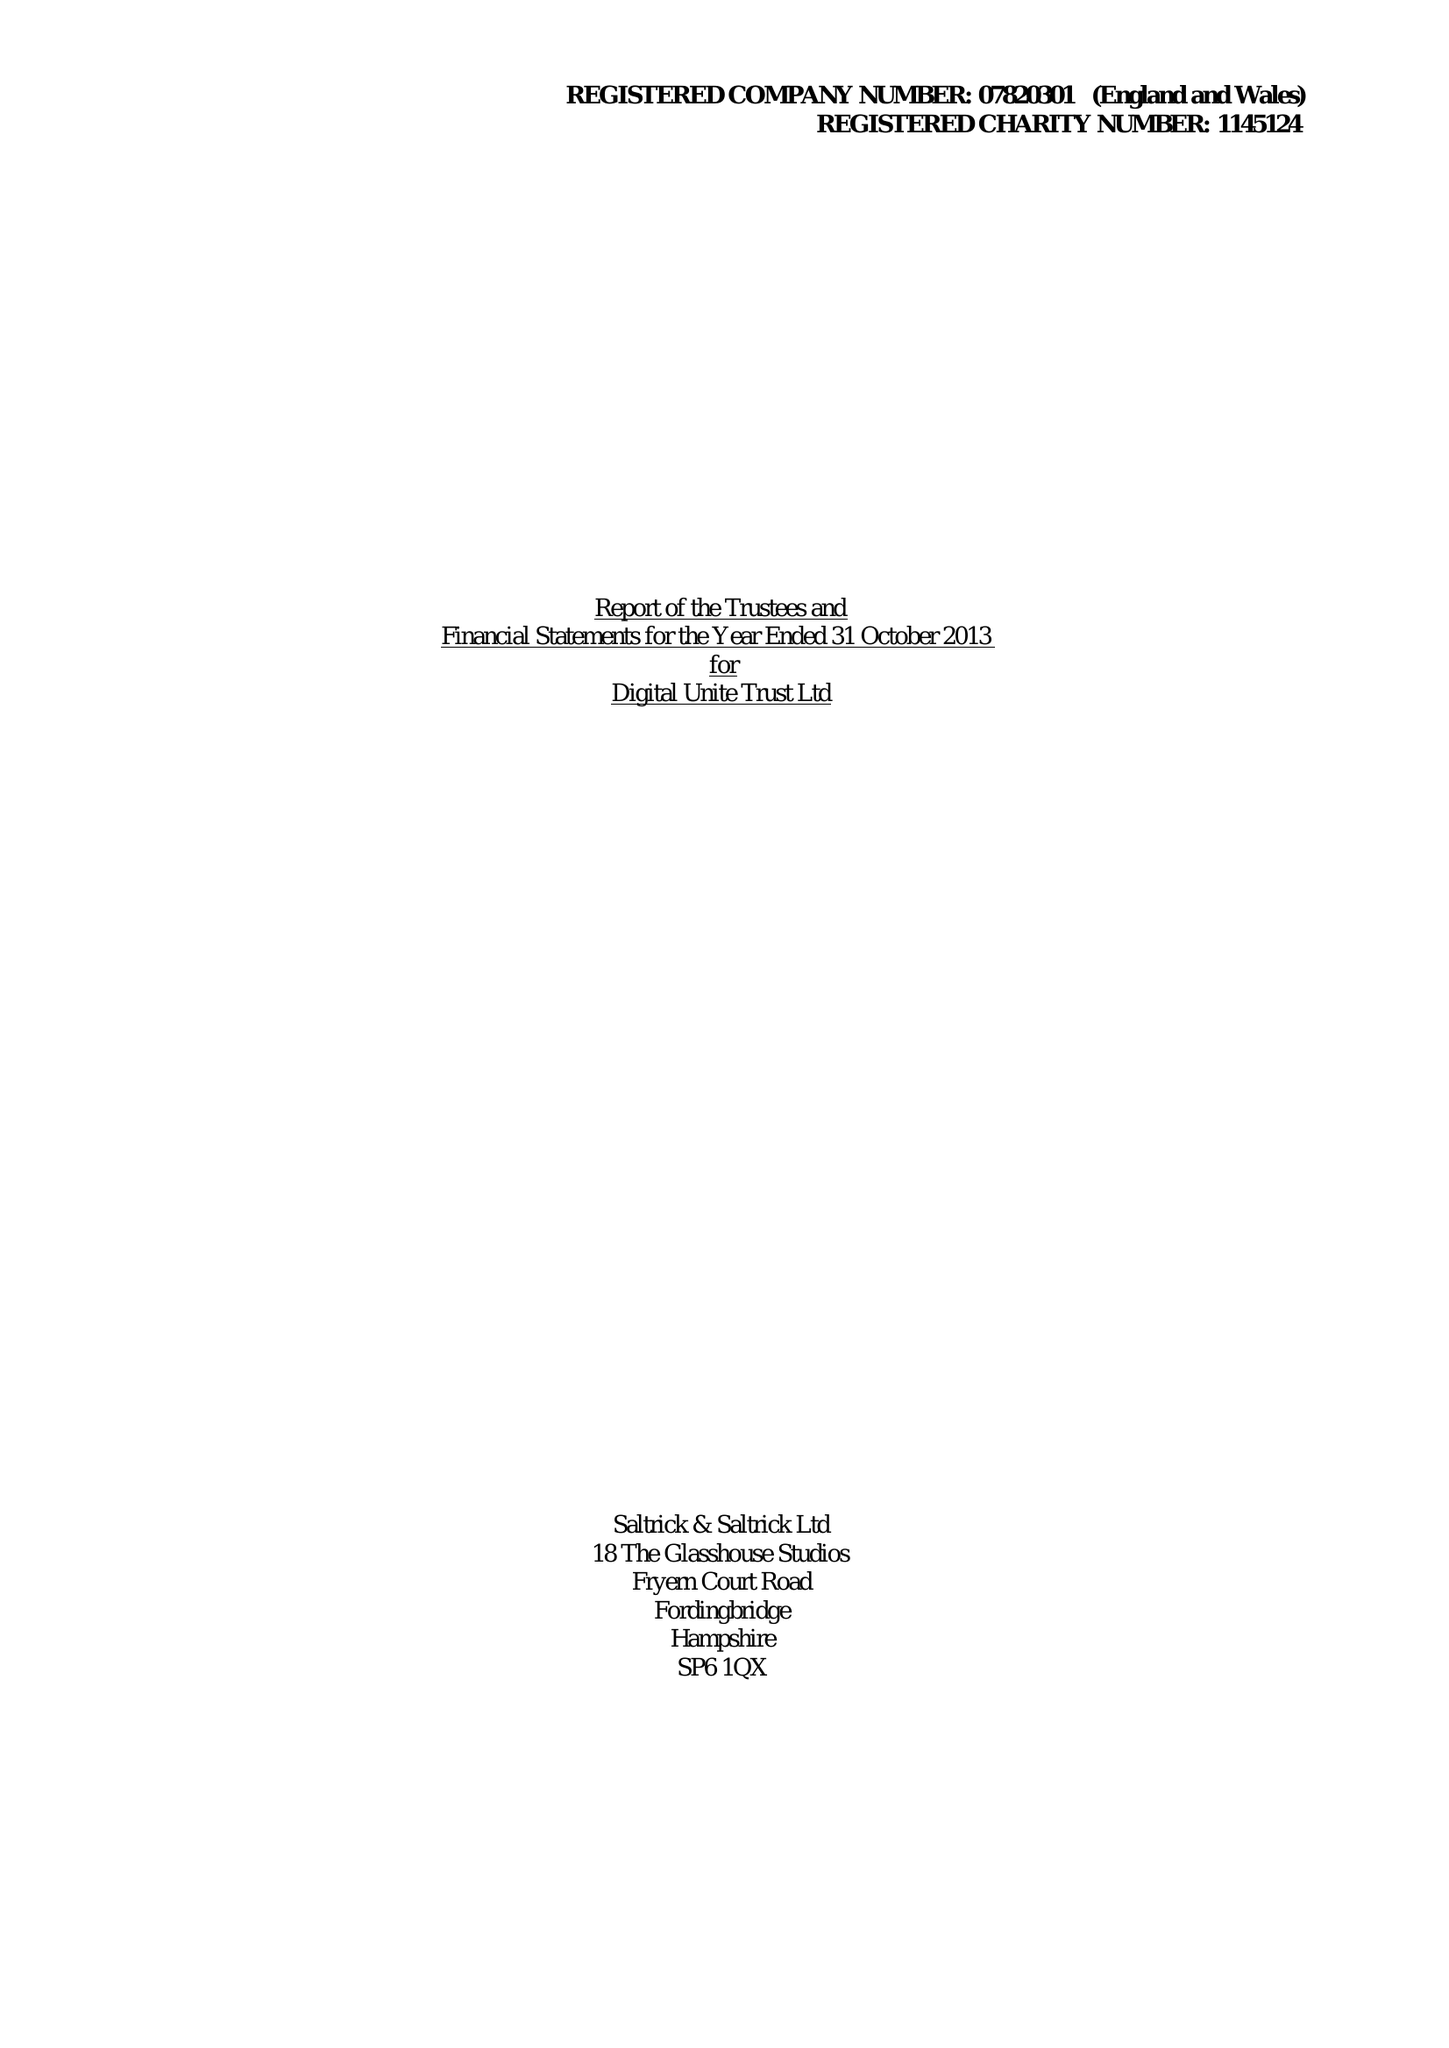What is the value for the charity_name?
Answer the question using a single word or phrase. Digital Unite Trust Ltd. 